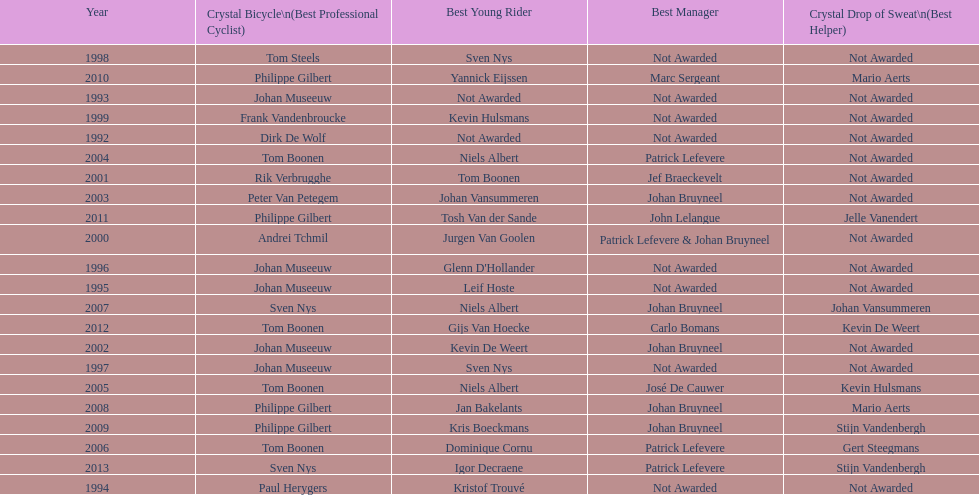What is the average number of times johan museeuw starred? 5. 